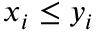Convert formula to latex. <formula><loc_0><loc_0><loc_500><loc_500>x _ { i } \leq y _ { i }</formula> 